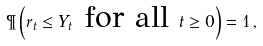Convert formula to latex. <formula><loc_0><loc_0><loc_500><loc_500>\P \left ( r _ { t } \leq Y _ { t } \text { for all } t \geq 0 \right ) = 1 \, ,</formula> 